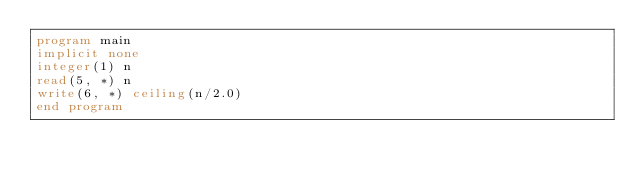Convert code to text. <code><loc_0><loc_0><loc_500><loc_500><_FORTRAN_>program main
implicit none
integer(1) n
read(5, *) n
write(6, *) ceiling(n/2.0)
end program
</code> 